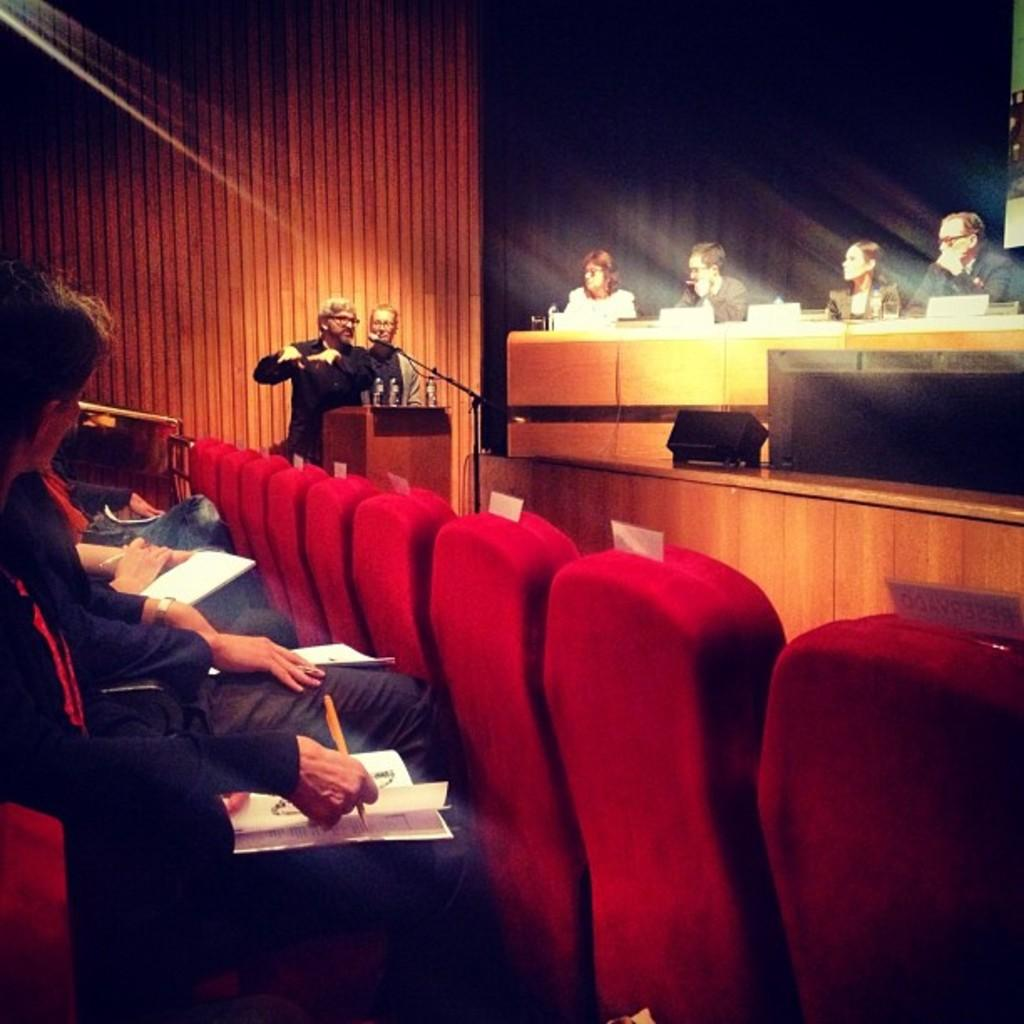What is the man in the image doing? The man is at a podium in the image, and he is speaking. Who is present in the image besides the man at the podium? There are people on either side of the man, and they are listening to him. How many cats are sitting on the man's lap in the image? There are no cats present in the image; the man is at a podium speaking to a group of people. 